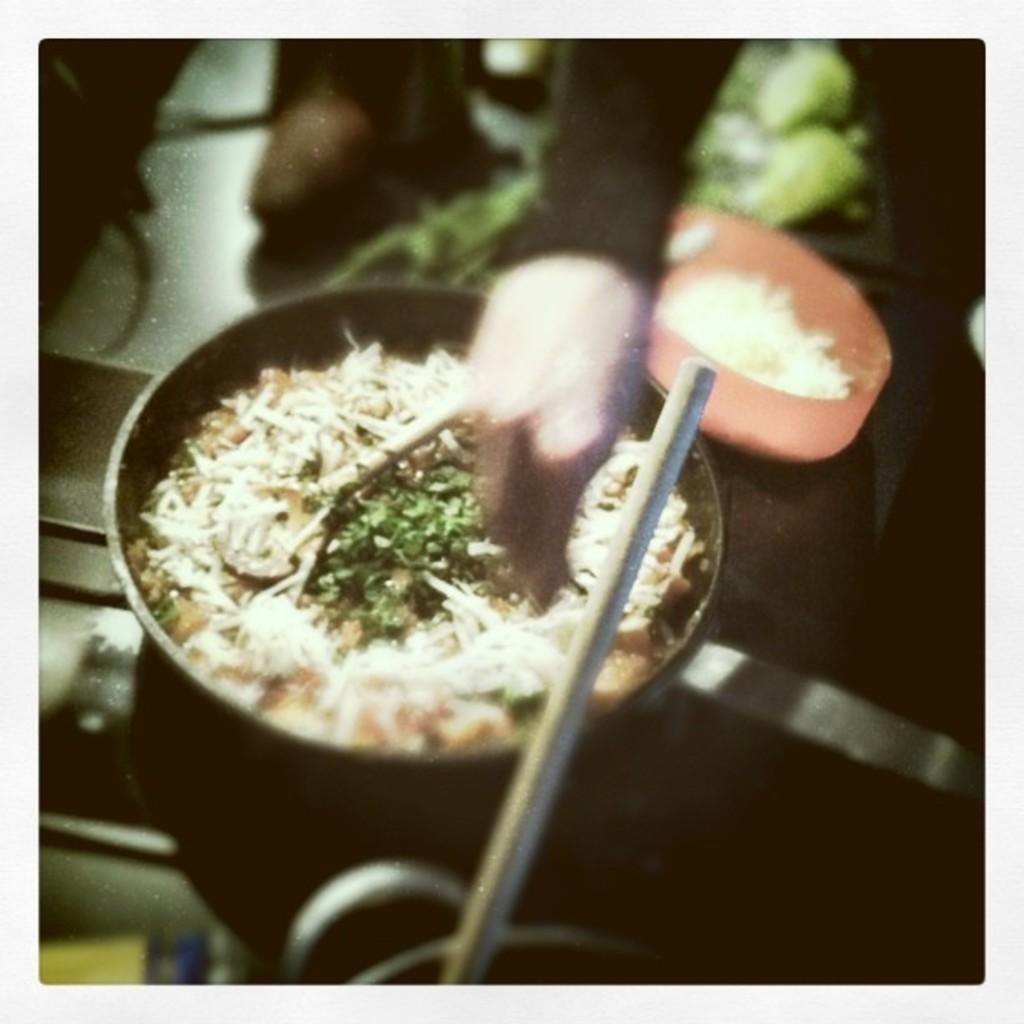What part of a person's body is visible in the image? There is a person's hand in the image. What is the person holding in the image? There is a pan in the image. What is in the bowl that the person is holding? There is a bowl with food in the image. Can you see any mice or their nests in the image? There are no mice or their nests present in the image. What type of blade is being used to prepare the food in the image? There is no blade visible in the image; it only shows a person's hand, a pan, and a bowl with food. 